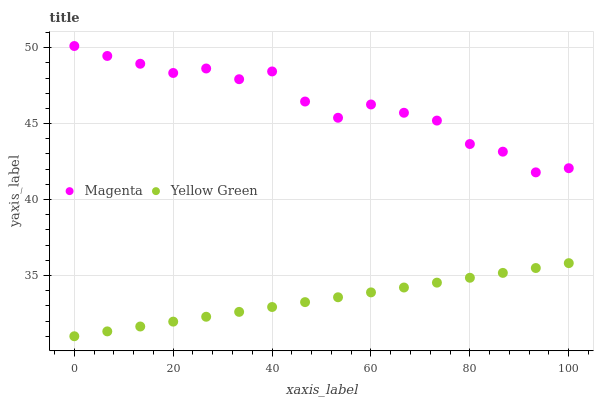Does Yellow Green have the minimum area under the curve?
Answer yes or no. Yes. Does Magenta have the maximum area under the curve?
Answer yes or no. Yes. Does Yellow Green have the maximum area under the curve?
Answer yes or no. No. Is Yellow Green the smoothest?
Answer yes or no. Yes. Is Magenta the roughest?
Answer yes or no. Yes. Is Yellow Green the roughest?
Answer yes or no. No. Does Yellow Green have the lowest value?
Answer yes or no. Yes. Does Magenta have the highest value?
Answer yes or no. Yes. Does Yellow Green have the highest value?
Answer yes or no. No. Is Yellow Green less than Magenta?
Answer yes or no. Yes. Is Magenta greater than Yellow Green?
Answer yes or no. Yes. Does Yellow Green intersect Magenta?
Answer yes or no. No. 